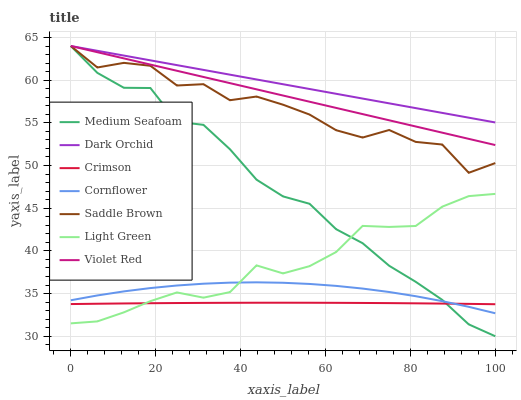Does Violet Red have the minimum area under the curve?
Answer yes or no. No. Does Violet Red have the maximum area under the curve?
Answer yes or no. No. Is Dark Orchid the smoothest?
Answer yes or no. No. Is Dark Orchid the roughest?
Answer yes or no. No. Does Violet Red have the lowest value?
Answer yes or no. No. Does Light Green have the highest value?
Answer yes or no. No. Is Light Green less than Dark Orchid?
Answer yes or no. Yes. Is Dark Orchid greater than Crimson?
Answer yes or no. Yes. Does Light Green intersect Dark Orchid?
Answer yes or no. No. 